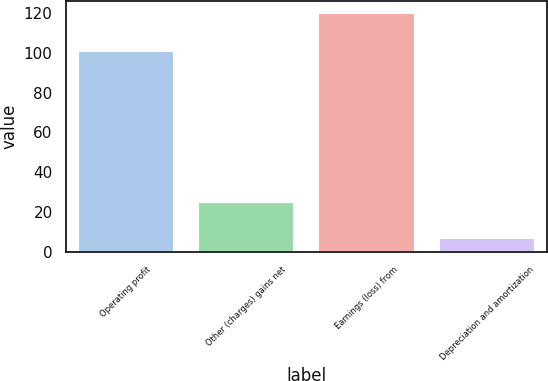<chart> <loc_0><loc_0><loc_500><loc_500><bar_chart><fcel>Operating profit<fcel>Other (charges) gains net<fcel>Earnings (loss) from<fcel>Depreciation and amortization<nl><fcel>101<fcel>25<fcel>120<fcel>7<nl></chart> 